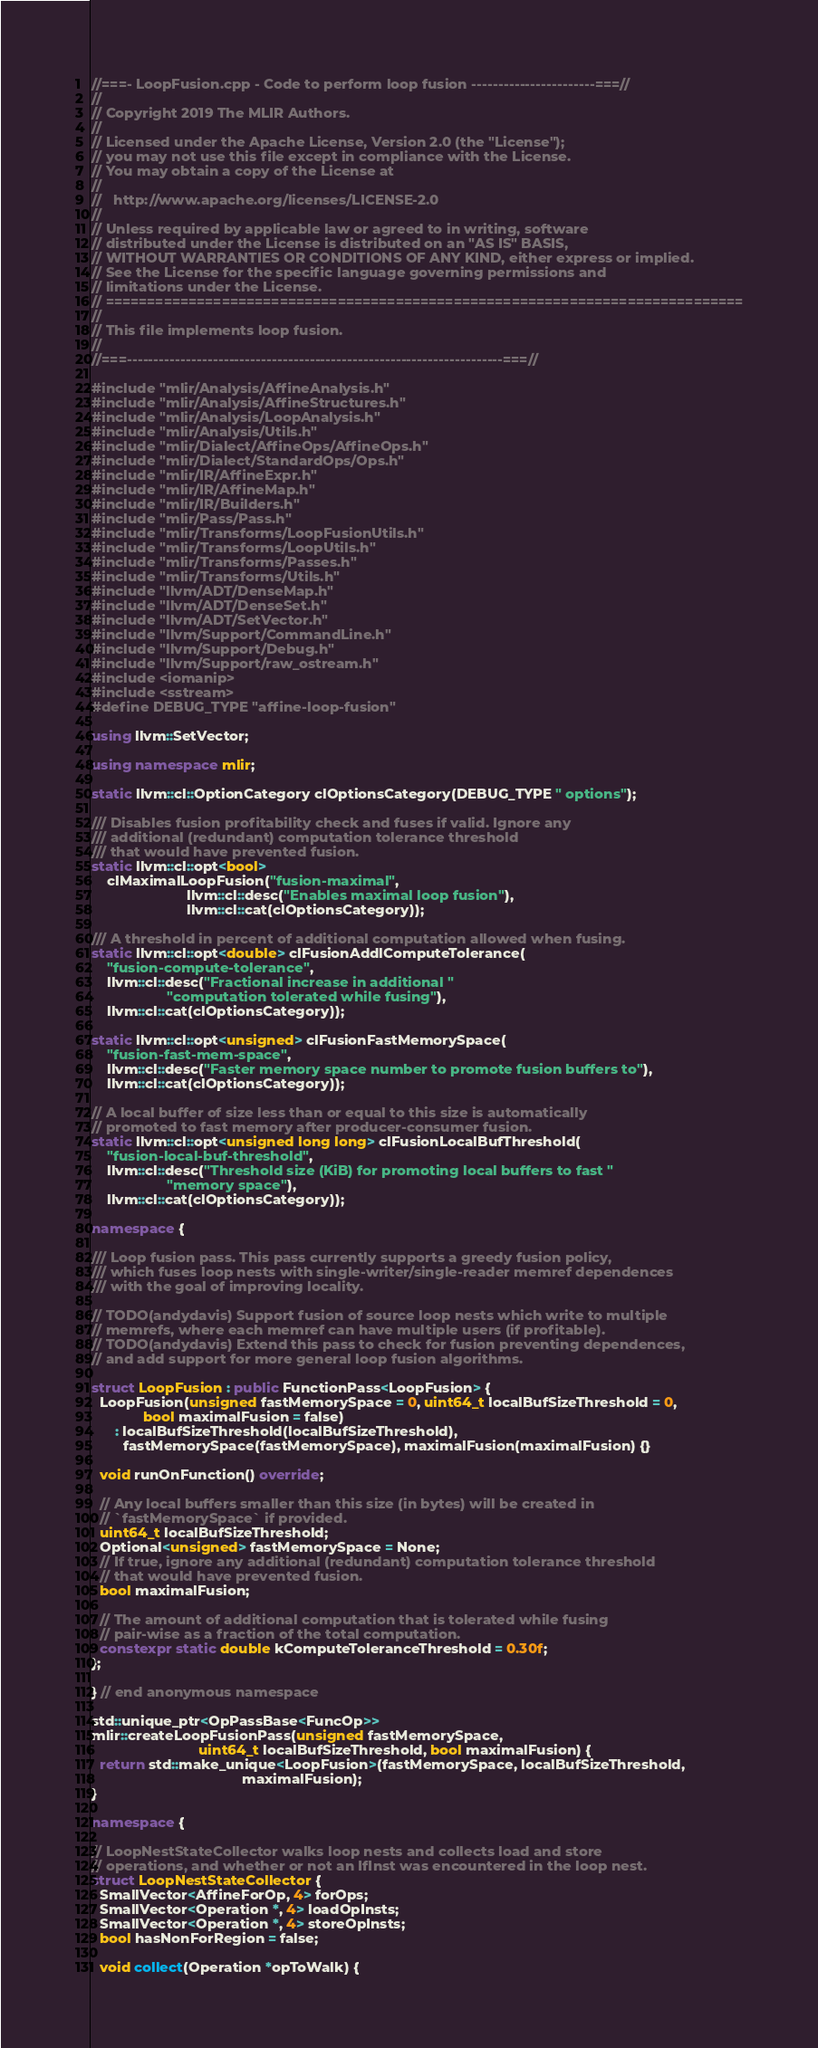Convert code to text. <code><loc_0><loc_0><loc_500><loc_500><_C++_>//===- LoopFusion.cpp - Code to perform loop fusion -----------------------===//
//
// Copyright 2019 The MLIR Authors.
//
// Licensed under the Apache License, Version 2.0 (the "License");
// you may not use this file except in compliance with the License.
// You may obtain a copy of the License at
//
//   http://www.apache.org/licenses/LICENSE-2.0
//
// Unless required by applicable law or agreed to in writing, software
// distributed under the License is distributed on an "AS IS" BASIS,
// WITHOUT WARRANTIES OR CONDITIONS OF ANY KIND, either express or implied.
// See the License for the specific language governing permissions and
// limitations under the License.
// =============================================================================
//
// This file implements loop fusion.
//
//===----------------------------------------------------------------------===//

#include "mlir/Analysis/AffineAnalysis.h"
#include "mlir/Analysis/AffineStructures.h"
#include "mlir/Analysis/LoopAnalysis.h"
#include "mlir/Analysis/Utils.h"
#include "mlir/Dialect/AffineOps/AffineOps.h"
#include "mlir/Dialect/StandardOps/Ops.h"
#include "mlir/IR/AffineExpr.h"
#include "mlir/IR/AffineMap.h"
#include "mlir/IR/Builders.h"
#include "mlir/Pass/Pass.h"
#include "mlir/Transforms/LoopFusionUtils.h"
#include "mlir/Transforms/LoopUtils.h"
#include "mlir/Transforms/Passes.h"
#include "mlir/Transforms/Utils.h"
#include "llvm/ADT/DenseMap.h"
#include "llvm/ADT/DenseSet.h"
#include "llvm/ADT/SetVector.h"
#include "llvm/Support/CommandLine.h"
#include "llvm/Support/Debug.h"
#include "llvm/Support/raw_ostream.h"
#include <iomanip>
#include <sstream>
#define DEBUG_TYPE "affine-loop-fusion"

using llvm::SetVector;

using namespace mlir;

static llvm::cl::OptionCategory clOptionsCategory(DEBUG_TYPE " options");

/// Disables fusion profitability check and fuses if valid. Ignore any
/// additional (redundant) computation tolerance threshold
/// that would have prevented fusion.
static llvm::cl::opt<bool>
    clMaximalLoopFusion("fusion-maximal",
                        llvm::cl::desc("Enables maximal loop fusion"),
                        llvm::cl::cat(clOptionsCategory));

/// A threshold in percent of additional computation allowed when fusing.
static llvm::cl::opt<double> clFusionAddlComputeTolerance(
    "fusion-compute-tolerance",
    llvm::cl::desc("Fractional increase in additional "
                   "computation tolerated while fusing"),
    llvm::cl::cat(clOptionsCategory));

static llvm::cl::opt<unsigned> clFusionFastMemorySpace(
    "fusion-fast-mem-space",
    llvm::cl::desc("Faster memory space number to promote fusion buffers to"),
    llvm::cl::cat(clOptionsCategory));

// A local buffer of size less than or equal to this size is automatically
// promoted to fast memory after producer-consumer fusion.
static llvm::cl::opt<unsigned long long> clFusionLocalBufThreshold(
    "fusion-local-buf-threshold",
    llvm::cl::desc("Threshold size (KiB) for promoting local buffers to fast "
                   "memory space"),
    llvm::cl::cat(clOptionsCategory));

namespace {

/// Loop fusion pass. This pass currently supports a greedy fusion policy,
/// which fuses loop nests with single-writer/single-reader memref dependences
/// with the goal of improving locality.

// TODO(andydavis) Support fusion of source loop nests which write to multiple
// memrefs, where each memref can have multiple users (if profitable).
// TODO(andydavis) Extend this pass to check for fusion preventing dependences,
// and add support for more general loop fusion algorithms.

struct LoopFusion : public FunctionPass<LoopFusion> {
  LoopFusion(unsigned fastMemorySpace = 0, uint64_t localBufSizeThreshold = 0,
             bool maximalFusion = false)
      : localBufSizeThreshold(localBufSizeThreshold),
        fastMemorySpace(fastMemorySpace), maximalFusion(maximalFusion) {}

  void runOnFunction() override;

  // Any local buffers smaller than this size (in bytes) will be created in
  // `fastMemorySpace` if provided.
  uint64_t localBufSizeThreshold;
  Optional<unsigned> fastMemorySpace = None;
  // If true, ignore any additional (redundant) computation tolerance threshold
  // that would have prevented fusion.
  bool maximalFusion;

  // The amount of additional computation that is tolerated while fusing
  // pair-wise as a fraction of the total computation.
  constexpr static double kComputeToleranceThreshold = 0.30f;
};

} // end anonymous namespace

std::unique_ptr<OpPassBase<FuncOp>>
mlir::createLoopFusionPass(unsigned fastMemorySpace,
                           uint64_t localBufSizeThreshold, bool maximalFusion) {
  return std::make_unique<LoopFusion>(fastMemorySpace, localBufSizeThreshold,
                                      maximalFusion);
}

namespace {

// LoopNestStateCollector walks loop nests and collects load and store
// operations, and whether or not an IfInst was encountered in the loop nest.
struct LoopNestStateCollector {
  SmallVector<AffineForOp, 4> forOps;
  SmallVector<Operation *, 4> loadOpInsts;
  SmallVector<Operation *, 4> storeOpInsts;
  bool hasNonForRegion = false;

  void collect(Operation *opToWalk) {</code> 